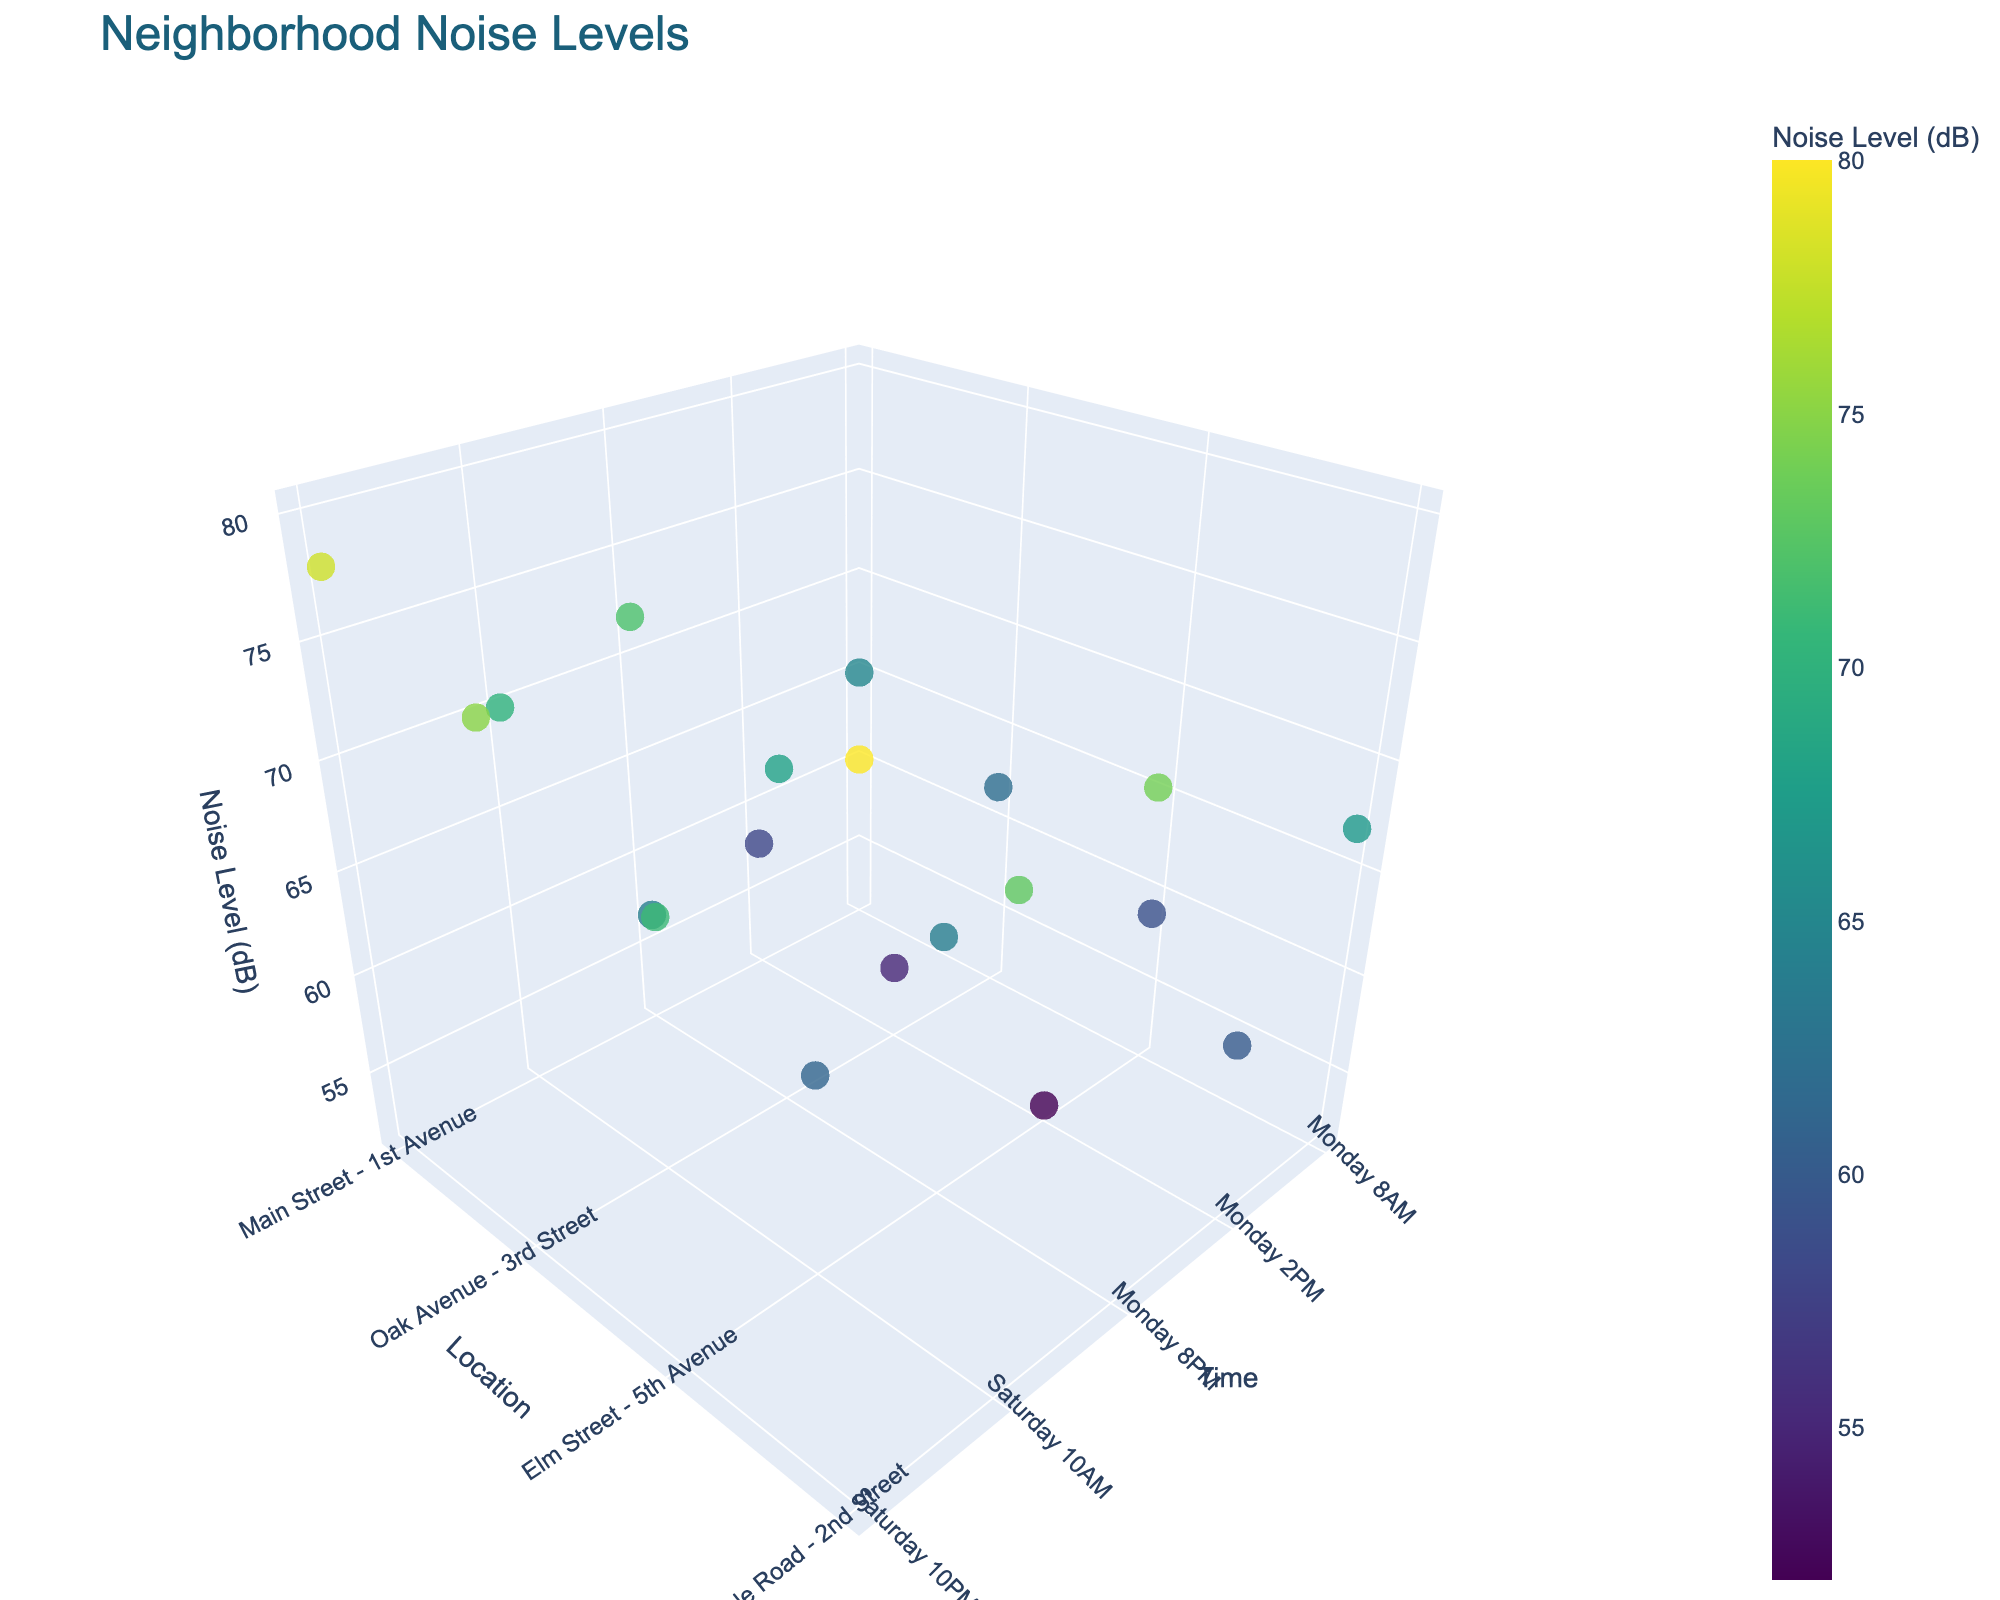What's the highest noise level recorded on Main Street - 1st Avenue? Look at the data points related to Main Street - 1st Avenue and find the one with the highest noise level. From the plot, Main Street - 1st Avenue on Saturday 10PM shows the highest noise level at 78 dB.
Answer: 78 dB Which time period has the highest overall noise level in the neighborhood? Examine all data points across different times. The time period with the highest overall noise level is Saturday 10PM, shown by the most data points with peak values, specifically Maple Road - 2nd Street shows 80 dB.
Answer: Saturday 10PM What is the average noise level at 8 PM on Monday across all locations? Calculate the noise levels at Monday 8PM for all locations: 72 (Main Street - 1st Avenue), 68 (Oak Avenue - 3rd Street), 64 (Elm Street - 5th Avenue), 74 (Maple Road - 2nd Street). Sum them up: 72 + 68 + 64 + 74 = 278 and divide by 4.
Answer: 69.5 dB Which location has the largest increase in noise level from Monday 8AM to Monday 8PM? Compare the noise levels at these specific times for each location. The differences are: Main Street - 1st Avenue (72 - 65 = 7 dB), Oak Avenue - 3rd Street (68 - 62 = 6 dB), Elm Street - 5th Avenue (64 - 59 = 5 dB), Maple Road - 2nd Street (74 - 67 = 7 dB).
Answer: Tie: Main Street - 1st Avenue, Maple Road - 2nd Street At which location is the noise level lowest on Monday at 2 PM? Check the noise levels specifically at Monday 2PM across various locations: 58 (Main Street - 1st Avenue), 55 (Oak Avenue - 3rd Street), 52 (Elm Street - 5th Avenue), 60 (Maple Road - 2nd Street). The lowest value is at Elm Street - 5th Avenue with 52 dB.
Answer: Elm Street - 5th Avenue Which location has consistently high noise levels regardless of the time of day? Identify one location that remains relatively high across different times. Maple Road - 2nd Street stands out with values 67, 60, 74, 73, and 80 dB. This location shows consistently high values.
Answer: Maple Road - 2nd Street What is the range of noise levels recorded at Oak Avenue - 3rd Street? Identify the highest and lowest noise levels at Oak Avenue - 3rd Street: 75 (highest) and 55 (lowest). The range is the difference between these two values (75 - 55).
Answer: 20 dB How do noise levels on Main Street - 1st Avenue on Saturday compare to Monday? Compare the noise levels at Main Street - 1st Avenue on Saturday (70 dB at 10AM and 78 dB at 10PM) to Monday (65 dB at 8AM, 58 dB at 2PM, 72 dB at 8PM). Saturday's values are higher overall.
Answer: Higher on Saturday 